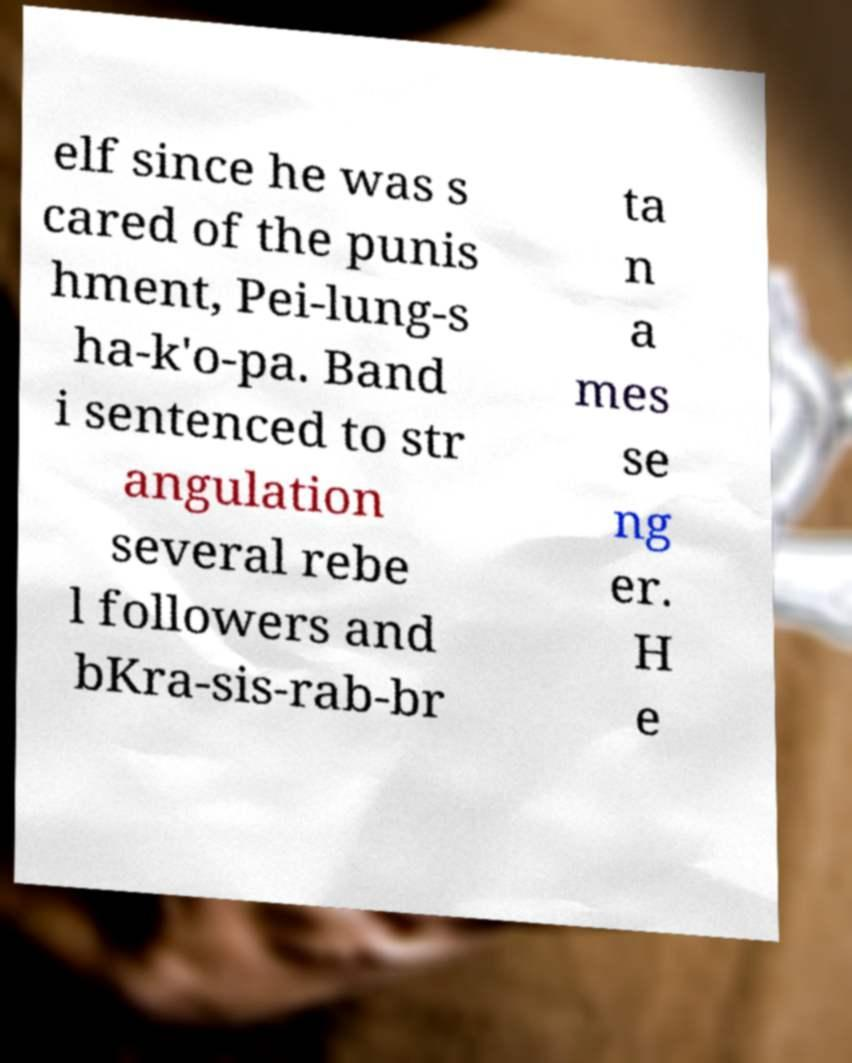I need the written content from this picture converted into text. Can you do that? elf since he was s cared of the punis hment, Pei-lung-s ha-k'o-pa. Band i sentenced to str angulation several rebe l followers and bKra-sis-rab-br ta n a mes se ng er. H e 